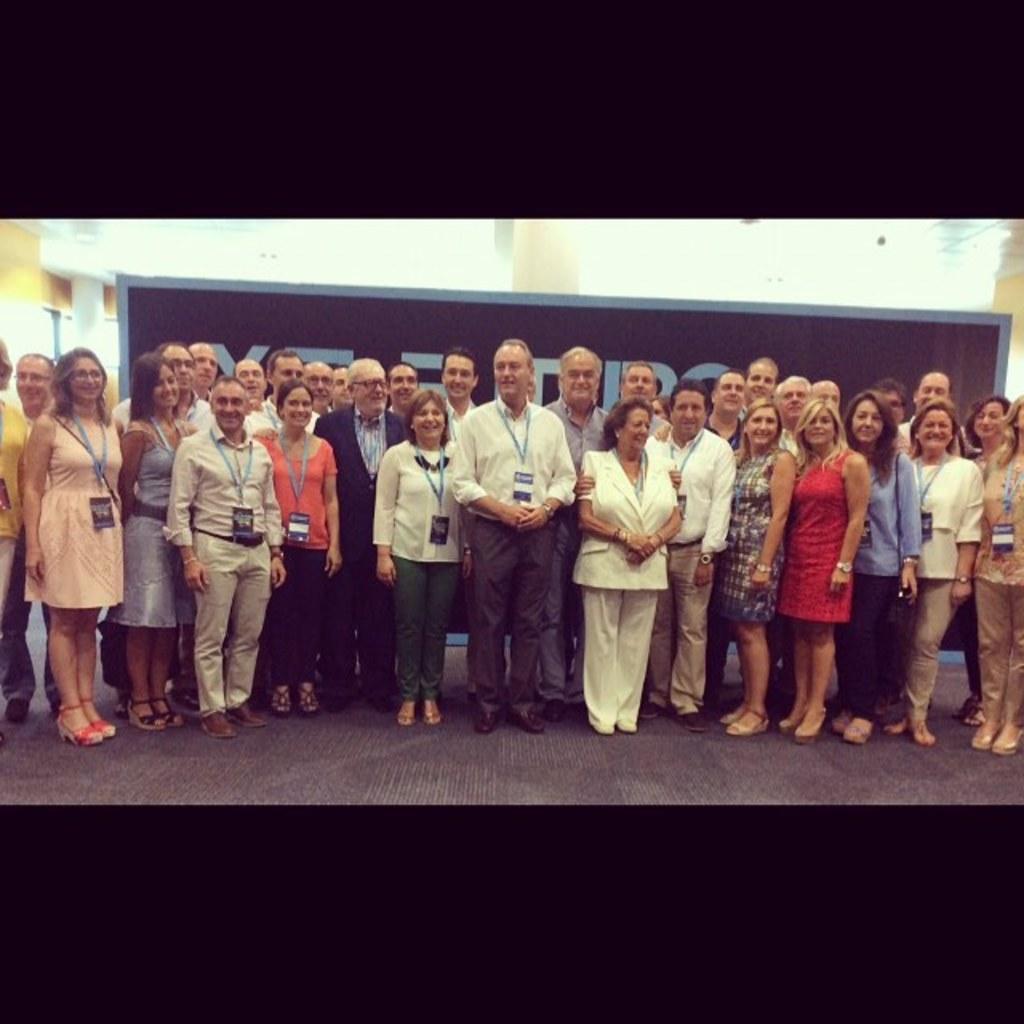Describe this image in one or two sentences. In this image we can see a group of people standing and few people wearing the identity cards. There is some text on the board in the image. 